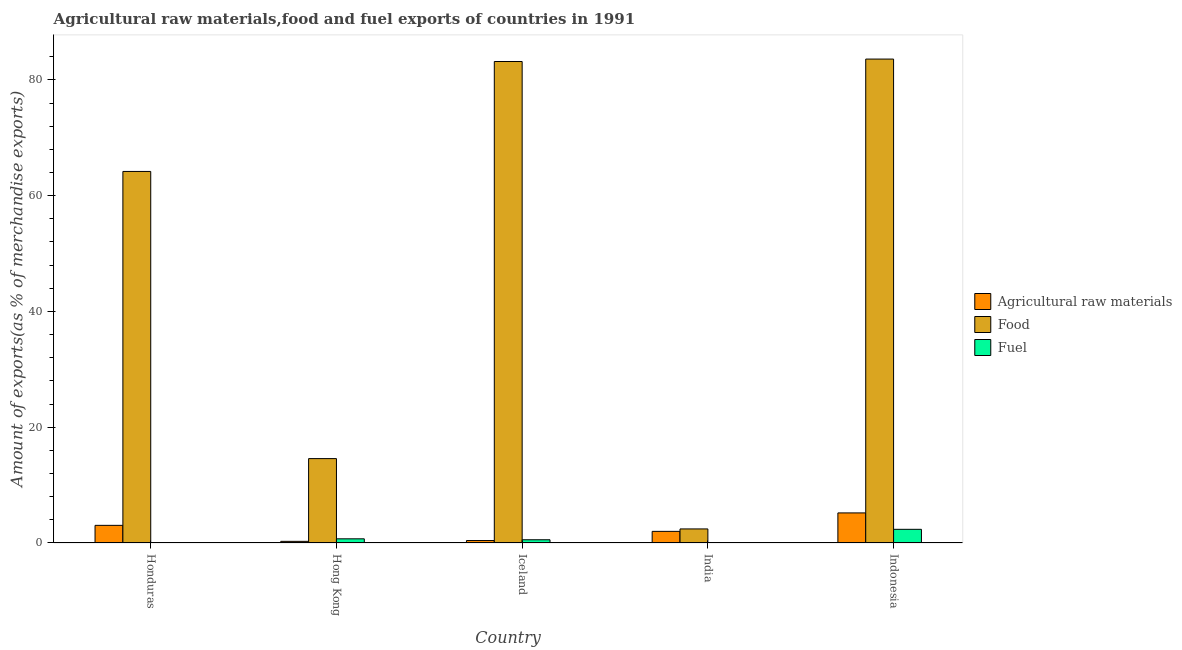How many different coloured bars are there?
Offer a terse response. 3. How many groups of bars are there?
Your answer should be compact. 5. Are the number of bars per tick equal to the number of legend labels?
Make the answer very short. Yes. How many bars are there on the 5th tick from the left?
Your answer should be compact. 3. What is the label of the 3rd group of bars from the left?
Make the answer very short. Iceland. In how many cases, is the number of bars for a given country not equal to the number of legend labels?
Offer a very short reply. 0. What is the percentage of fuel exports in Honduras?
Give a very brief answer. 0.01. Across all countries, what is the maximum percentage of fuel exports?
Ensure brevity in your answer.  2.36. Across all countries, what is the minimum percentage of fuel exports?
Make the answer very short. 0.01. In which country was the percentage of food exports maximum?
Give a very brief answer. Indonesia. In which country was the percentage of raw materials exports minimum?
Offer a terse response. Hong Kong. What is the total percentage of raw materials exports in the graph?
Provide a succinct answer. 10.96. What is the difference between the percentage of fuel exports in Hong Kong and that in Iceland?
Give a very brief answer. 0.16. What is the difference between the percentage of raw materials exports in Honduras and the percentage of food exports in Iceland?
Your answer should be compact. -80.13. What is the average percentage of food exports per country?
Your answer should be very brief. 49.6. What is the difference between the percentage of raw materials exports and percentage of fuel exports in India?
Your answer should be very brief. 1.96. In how many countries, is the percentage of raw materials exports greater than 76 %?
Make the answer very short. 0. What is the ratio of the percentage of food exports in Honduras to that in Indonesia?
Provide a succinct answer. 0.77. What is the difference between the highest and the second highest percentage of raw materials exports?
Offer a very short reply. 2.15. What is the difference between the highest and the lowest percentage of fuel exports?
Ensure brevity in your answer.  2.35. Is the sum of the percentage of fuel exports in Iceland and India greater than the maximum percentage of food exports across all countries?
Your response must be concise. No. What does the 2nd bar from the left in India represents?
Make the answer very short. Food. What does the 1st bar from the right in Indonesia represents?
Your answer should be very brief. Fuel. Is it the case that in every country, the sum of the percentage of raw materials exports and percentage of food exports is greater than the percentage of fuel exports?
Your answer should be very brief. Yes. How many bars are there?
Keep it short and to the point. 15. How many countries are there in the graph?
Provide a short and direct response. 5. Are the values on the major ticks of Y-axis written in scientific E-notation?
Your answer should be compact. No. Does the graph contain any zero values?
Keep it short and to the point. No. How are the legend labels stacked?
Your response must be concise. Vertical. What is the title of the graph?
Your response must be concise. Agricultural raw materials,food and fuel exports of countries in 1991. What is the label or title of the Y-axis?
Provide a short and direct response. Amount of exports(as % of merchandise exports). What is the Amount of exports(as % of merchandise exports) in Agricultural raw materials in Honduras?
Your answer should be very brief. 3.05. What is the Amount of exports(as % of merchandise exports) in Food in Honduras?
Provide a short and direct response. 64.19. What is the Amount of exports(as % of merchandise exports) of Fuel in Honduras?
Offer a very short reply. 0.01. What is the Amount of exports(as % of merchandise exports) in Agricultural raw materials in Hong Kong?
Keep it short and to the point. 0.28. What is the Amount of exports(as % of merchandise exports) of Food in Hong Kong?
Provide a short and direct response. 14.58. What is the Amount of exports(as % of merchandise exports) of Fuel in Hong Kong?
Give a very brief answer. 0.72. What is the Amount of exports(as % of merchandise exports) of Agricultural raw materials in Iceland?
Offer a very short reply. 0.42. What is the Amount of exports(as % of merchandise exports) of Food in Iceland?
Your answer should be very brief. 83.18. What is the Amount of exports(as % of merchandise exports) in Fuel in Iceland?
Ensure brevity in your answer.  0.56. What is the Amount of exports(as % of merchandise exports) of Agricultural raw materials in India?
Offer a very short reply. 2.01. What is the Amount of exports(as % of merchandise exports) in Food in India?
Offer a very short reply. 2.43. What is the Amount of exports(as % of merchandise exports) in Fuel in India?
Provide a short and direct response. 0.05. What is the Amount of exports(as % of merchandise exports) in Agricultural raw materials in Indonesia?
Offer a very short reply. 5.2. What is the Amount of exports(as % of merchandise exports) of Food in Indonesia?
Provide a succinct answer. 83.6. What is the Amount of exports(as % of merchandise exports) in Fuel in Indonesia?
Provide a succinct answer. 2.36. Across all countries, what is the maximum Amount of exports(as % of merchandise exports) of Agricultural raw materials?
Provide a short and direct response. 5.2. Across all countries, what is the maximum Amount of exports(as % of merchandise exports) in Food?
Give a very brief answer. 83.6. Across all countries, what is the maximum Amount of exports(as % of merchandise exports) in Fuel?
Provide a short and direct response. 2.36. Across all countries, what is the minimum Amount of exports(as % of merchandise exports) in Agricultural raw materials?
Provide a short and direct response. 0.28. Across all countries, what is the minimum Amount of exports(as % of merchandise exports) of Food?
Ensure brevity in your answer.  2.43. Across all countries, what is the minimum Amount of exports(as % of merchandise exports) of Fuel?
Make the answer very short. 0.01. What is the total Amount of exports(as % of merchandise exports) of Agricultural raw materials in the graph?
Your answer should be very brief. 10.96. What is the total Amount of exports(as % of merchandise exports) in Food in the graph?
Provide a succinct answer. 247.98. What is the total Amount of exports(as % of merchandise exports) of Fuel in the graph?
Offer a terse response. 3.7. What is the difference between the Amount of exports(as % of merchandise exports) in Agricultural raw materials in Honduras and that in Hong Kong?
Give a very brief answer. 2.76. What is the difference between the Amount of exports(as % of merchandise exports) of Food in Honduras and that in Hong Kong?
Your response must be concise. 49.61. What is the difference between the Amount of exports(as % of merchandise exports) of Fuel in Honduras and that in Hong Kong?
Keep it short and to the point. -0.71. What is the difference between the Amount of exports(as % of merchandise exports) in Agricultural raw materials in Honduras and that in Iceland?
Provide a short and direct response. 2.62. What is the difference between the Amount of exports(as % of merchandise exports) of Food in Honduras and that in Iceland?
Offer a very short reply. -18.99. What is the difference between the Amount of exports(as % of merchandise exports) of Fuel in Honduras and that in Iceland?
Offer a very short reply. -0.55. What is the difference between the Amount of exports(as % of merchandise exports) in Agricultural raw materials in Honduras and that in India?
Provide a succinct answer. 1.04. What is the difference between the Amount of exports(as % of merchandise exports) of Food in Honduras and that in India?
Provide a short and direct response. 61.76. What is the difference between the Amount of exports(as % of merchandise exports) of Fuel in Honduras and that in India?
Provide a short and direct response. -0.04. What is the difference between the Amount of exports(as % of merchandise exports) of Agricultural raw materials in Honduras and that in Indonesia?
Your response must be concise. -2.15. What is the difference between the Amount of exports(as % of merchandise exports) of Food in Honduras and that in Indonesia?
Offer a terse response. -19.41. What is the difference between the Amount of exports(as % of merchandise exports) in Fuel in Honduras and that in Indonesia?
Give a very brief answer. -2.35. What is the difference between the Amount of exports(as % of merchandise exports) in Agricultural raw materials in Hong Kong and that in Iceland?
Your answer should be compact. -0.14. What is the difference between the Amount of exports(as % of merchandise exports) of Food in Hong Kong and that in Iceland?
Ensure brevity in your answer.  -68.6. What is the difference between the Amount of exports(as % of merchandise exports) in Fuel in Hong Kong and that in Iceland?
Give a very brief answer. 0.16. What is the difference between the Amount of exports(as % of merchandise exports) in Agricultural raw materials in Hong Kong and that in India?
Provide a succinct answer. -1.73. What is the difference between the Amount of exports(as % of merchandise exports) in Food in Hong Kong and that in India?
Your response must be concise. 12.15. What is the difference between the Amount of exports(as % of merchandise exports) in Fuel in Hong Kong and that in India?
Offer a terse response. 0.67. What is the difference between the Amount of exports(as % of merchandise exports) in Agricultural raw materials in Hong Kong and that in Indonesia?
Your answer should be very brief. -4.91. What is the difference between the Amount of exports(as % of merchandise exports) of Food in Hong Kong and that in Indonesia?
Your response must be concise. -69.02. What is the difference between the Amount of exports(as % of merchandise exports) of Fuel in Hong Kong and that in Indonesia?
Offer a terse response. -1.64. What is the difference between the Amount of exports(as % of merchandise exports) in Agricultural raw materials in Iceland and that in India?
Keep it short and to the point. -1.59. What is the difference between the Amount of exports(as % of merchandise exports) of Food in Iceland and that in India?
Offer a very short reply. 80.75. What is the difference between the Amount of exports(as % of merchandise exports) of Fuel in Iceland and that in India?
Provide a short and direct response. 0.51. What is the difference between the Amount of exports(as % of merchandise exports) in Agricultural raw materials in Iceland and that in Indonesia?
Your response must be concise. -4.77. What is the difference between the Amount of exports(as % of merchandise exports) in Food in Iceland and that in Indonesia?
Your answer should be compact. -0.42. What is the difference between the Amount of exports(as % of merchandise exports) of Fuel in Iceland and that in Indonesia?
Make the answer very short. -1.8. What is the difference between the Amount of exports(as % of merchandise exports) in Agricultural raw materials in India and that in Indonesia?
Provide a succinct answer. -3.19. What is the difference between the Amount of exports(as % of merchandise exports) in Food in India and that in Indonesia?
Offer a very short reply. -81.17. What is the difference between the Amount of exports(as % of merchandise exports) in Fuel in India and that in Indonesia?
Keep it short and to the point. -2.31. What is the difference between the Amount of exports(as % of merchandise exports) of Agricultural raw materials in Honduras and the Amount of exports(as % of merchandise exports) of Food in Hong Kong?
Your response must be concise. -11.53. What is the difference between the Amount of exports(as % of merchandise exports) in Agricultural raw materials in Honduras and the Amount of exports(as % of merchandise exports) in Fuel in Hong Kong?
Provide a succinct answer. 2.33. What is the difference between the Amount of exports(as % of merchandise exports) in Food in Honduras and the Amount of exports(as % of merchandise exports) in Fuel in Hong Kong?
Your response must be concise. 63.47. What is the difference between the Amount of exports(as % of merchandise exports) in Agricultural raw materials in Honduras and the Amount of exports(as % of merchandise exports) in Food in Iceland?
Your answer should be compact. -80.13. What is the difference between the Amount of exports(as % of merchandise exports) in Agricultural raw materials in Honduras and the Amount of exports(as % of merchandise exports) in Fuel in Iceland?
Offer a terse response. 2.49. What is the difference between the Amount of exports(as % of merchandise exports) in Food in Honduras and the Amount of exports(as % of merchandise exports) in Fuel in Iceland?
Keep it short and to the point. 63.63. What is the difference between the Amount of exports(as % of merchandise exports) in Agricultural raw materials in Honduras and the Amount of exports(as % of merchandise exports) in Food in India?
Offer a terse response. 0.62. What is the difference between the Amount of exports(as % of merchandise exports) of Agricultural raw materials in Honduras and the Amount of exports(as % of merchandise exports) of Fuel in India?
Make the answer very short. 3. What is the difference between the Amount of exports(as % of merchandise exports) of Food in Honduras and the Amount of exports(as % of merchandise exports) of Fuel in India?
Give a very brief answer. 64.14. What is the difference between the Amount of exports(as % of merchandise exports) in Agricultural raw materials in Honduras and the Amount of exports(as % of merchandise exports) in Food in Indonesia?
Your answer should be very brief. -80.56. What is the difference between the Amount of exports(as % of merchandise exports) of Agricultural raw materials in Honduras and the Amount of exports(as % of merchandise exports) of Fuel in Indonesia?
Ensure brevity in your answer.  0.68. What is the difference between the Amount of exports(as % of merchandise exports) in Food in Honduras and the Amount of exports(as % of merchandise exports) in Fuel in Indonesia?
Provide a short and direct response. 61.83. What is the difference between the Amount of exports(as % of merchandise exports) of Agricultural raw materials in Hong Kong and the Amount of exports(as % of merchandise exports) of Food in Iceland?
Give a very brief answer. -82.9. What is the difference between the Amount of exports(as % of merchandise exports) in Agricultural raw materials in Hong Kong and the Amount of exports(as % of merchandise exports) in Fuel in Iceland?
Make the answer very short. -0.28. What is the difference between the Amount of exports(as % of merchandise exports) of Food in Hong Kong and the Amount of exports(as % of merchandise exports) of Fuel in Iceland?
Offer a very short reply. 14.02. What is the difference between the Amount of exports(as % of merchandise exports) of Agricultural raw materials in Hong Kong and the Amount of exports(as % of merchandise exports) of Food in India?
Your response must be concise. -2.14. What is the difference between the Amount of exports(as % of merchandise exports) in Agricultural raw materials in Hong Kong and the Amount of exports(as % of merchandise exports) in Fuel in India?
Offer a terse response. 0.23. What is the difference between the Amount of exports(as % of merchandise exports) in Food in Hong Kong and the Amount of exports(as % of merchandise exports) in Fuel in India?
Make the answer very short. 14.53. What is the difference between the Amount of exports(as % of merchandise exports) of Agricultural raw materials in Hong Kong and the Amount of exports(as % of merchandise exports) of Food in Indonesia?
Keep it short and to the point. -83.32. What is the difference between the Amount of exports(as % of merchandise exports) in Agricultural raw materials in Hong Kong and the Amount of exports(as % of merchandise exports) in Fuel in Indonesia?
Ensure brevity in your answer.  -2.08. What is the difference between the Amount of exports(as % of merchandise exports) of Food in Hong Kong and the Amount of exports(as % of merchandise exports) of Fuel in Indonesia?
Offer a very short reply. 12.22. What is the difference between the Amount of exports(as % of merchandise exports) of Agricultural raw materials in Iceland and the Amount of exports(as % of merchandise exports) of Food in India?
Your answer should be very brief. -2.01. What is the difference between the Amount of exports(as % of merchandise exports) in Agricultural raw materials in Iceland and the Amount of exports(as % of merchandise exports) in Fuel in India?
Offer a very short reply. 0.37. What is the difference between the Amount of exports(as % of merchandise exports) in Food in Iceland and the Amount of exports(as % of merchandise exports) in Fuel in India?
Provide a succinct answer. 83.13. What is the difference between the Amount of exports(as % of merchandise exports) in Agricultural raw materials in Iceland and the Amount of exports(as % of merchandise exports) in Food in Indonesia?
Ensure brevity in your answer.  -83.18. What is the difference between the Amount of exports(as % of merchandise exports) in Agricultural raw materials in Iceland and the Amount of exports(as % of merchandise exports) in Fuel in Indonesia?
Provide a short and direct response. -1.94. What is the difference between the Amount of exports(as % of merchandise exports) of Food in Iceland and the Amount of exports(as % of merchandise exports) of Fuel in Indonesia?
Offer a terse response. 80.82. What is the difference between the Amount of exports(as % of merchandise exports) of Agricultural raw materials in India and the Amount of exports(as % of merchandise exports) of Food in Indonesia?
Keep it short and to the point. -81.59. What is the difference between the Amount of exports(as % of merchandise exports) in Agricultural raw materials in India and the Amount of exports(as % of merchandise exports) in Fuel in Indonesia?
Give a very brief answer. -0.35. What is the difference between the Amount of exports(as % of merchandise exports) in Food in India and the Amount of exports(as % of merchandise exports) in Fuel in Indonesia?
Your answer should be compact. 0.07. What is the average Amount of exports(as % of merchandise exports) of Agricultural raw materials per country?
Offer a very short reply. 2.19. What is the average Amount of exports(as % of merchandise exports) in Food per country?
Your answer should be compact. 49.6. What is the average Amount of exports(as % of merchandise exports) in Fuel per country?
Your response must be concise. 0.74. What is the difference between the Amount of exports(as % of merchandise exports) of Agricultural raw materials and Amount of exports(as % of merchandise exports) of Food in Honduras?
Provide a succinct answer. -61.14. What is the difference between the Amount of exports(as % of merchandise exports) of Agricultural raw materials and Amount of exports(as % of merchandise exports) of Fuel in Honduras?
Provide a succinct answer. 3.03. What is the difference between the Amount of exports(as % of merchandise exports) in Food and Amount of exports(as % of merchandise exports) in Fuel in Honduras?
Offer a very short reply. 64.18. What is the difference between the Amount of exports(as % of merchandise exports) of Agricultural raw materials and Amount of exports(as % of merchandise exports) of Food in Hong Kong?
Ensure brevity in your answer.  -14.3. What is the difference between the Amount of exports(as % of merchandise exports) in Agricultural raw materials and Amount of exports(as % of merchandise exports) in Fuel in Hong Kong?
Your response must be concise. -0.44. What is the difference between the Amount of exports(as % of merchandise exports) of Food and Amount of exports(as % of merchandise exports) of Fuel in Hong Kong?
Offer a terse response. 13.86. What is the difference between the Amount of exports(as % of merchandise exports) of Agricultural raw materials and Amount of exports(as % of merchandise exports) of Food in Iceland?
Ensure brevity in your answer.  -82.76. What is the difference between the Amount of exports(as % of merchandise exports) in Agricultural raw materials and Amount of exports(as % of merchandise exports) in Fuel in Iceland?
Give a very brief answer. -0.14. What is the difference between the Amount of exports(as % of merchandise exports) of Food and Amount of exports(as % of merchandise exports) of Fuel in Iceland?
Your response must be concise. 82.62. What is the difference between the Amount of exports(as % of merchandise exports) in Agricultural raw materials and Amount of exports(as % of merchandise exports) in Food in India?
Offer a terse response. -0.42. What is the difference between the Amount of exports(as % of merchandise exports) in Agricultural raw materials and Amount of exports(as % of merchandise exports) in Fuel in India?
Offer a very short reply. 1.96. What is the difference between the Amount of exports(as % of merchandise exports) of Food and Amount of exports(as % of merchandise exports) of Fuel in India?
Offer a very short reply. 2.38. What is the difference between the Amount of exports(as % of merchandise exports) of Agricultural raw materials and Amount of exports(as % of merchandise exports) of Food in Indonesia?
Provide a succinct answer. -78.41. What is the difference between the Amount of exports(as % of merchandise exports) in Agricultural raw materials and Amount of exports(as % of merchandise exports) in Fuel in Indonesia?
Provide a succinct answer. 2.83. What is the difference between the Amount of exports(as % of merchandise exports) in Food and Amount of exports(as % of merchandise exports) in Fuel in Indonesia?
Make the answer very short. 81.24. What is the ratio of the Amount of exports(as % of merchandise exports) of Agricultural raw materials in Honduras to that in Hong Kong?
Give a very brief answer. 10.78. What is the ratio of the Amount of exports(as % of merchandise exports) of Food in Honduras to that in Hong Kong?
Provide a succinct answer. 4.4. What is the ratio of the Amount of exports(as % of merchandise exports) in Fuel in Honduras to that in Hong Kong?
Offer a terse response. 0.02. What is the ratio of the Amount of exports(as % of merchandise exports) of Agricultural raw materials in Honduras to that in Iceland?
Keep it short and to the point. 7.21. What is the ratio of the Amount of exports(as % of merchandise exports) of Food in Honduras to that in Iceland?
Give a very brief answer. 0.77. What is the ratio of the Amount of exports(as % of merchandise exports) in Fuel in Honduras to that in Iceland?
Offer a terse response. 0.02. What is the ratio of the Amount of exports(as % of merchandise exports) in Agricultural raw materials in Honduras to that in India?
Your answer should be very brief. 1.52. What is the ratio of the Amount of exports(as % of merchandise exports) of Food in Honduras to that in India?
Provide a short and direct response. 26.44. What is the ratio of the Amount of exports(as % of merchandise exports) of Fuel in Honduras to that in India?
Your response must be concise. 0.23. What is the ratio of the Amount of exports(as % of merchandise exports) of Agricultural raw materials in Honduras to that in Indonesia?
Offer a terse response. 0.59. What is the ratio of the Amount of exports(as % of merchandise exports) of Food in Honduras to that in Indonesia?
Your answer should be very brief. 0.77. What is the ratio of the Amount of exports(as % of merchandise exports) of Fuel in Honduras to that in Indonesia?
Keep it short and to the point. 0. What is the ratio of the Amount of exports(as % of merchandise exports) in Agricultural raw materials in Hong Kong to that in Iceland?
Make the answer very short. 0.67. What is the ratio of the Amount of exports(as % of merchandise exports) in Food in Hong Kong to that in Iceland?
Offer a very short reply. 0.18. What is the ratio of the Amount of exports(as % of merchandise exports) of Fuel in Hong Kong to that in Iceland?
Give a very brief answer. 1.29. What is the ratio of the Amount of exports(as % of merchandise exports) in Agricultural raw materials in Hong Kong to that in India?
Your answer should be very brief. 0.14. What is the ratio of the Amount of exports(as % of merchandise exports) of Food in Hong Kong to that in India?
Provide a succinct answer. 6.01. What is the ratio of the Amount of exports(as % of merchandise exports) of Fuel in Hong Kong to that in India?
Keep it short and to the point. 14.62. What is the ratio of the Amount of exports(as % of merchandise exports) of Agricultural raw materials in Hong Kong to that in Indonesia?
Ensure brevity in your answer.  0.05. What is the ratio of the Amount of exports(as % of merchandise exports) in Food in Hong Kong to that in Indonesia?
Offer a very short reply. 0.17. What is the ratio of the Amount of exports(as % of merchandise exports) of Fuel in Hong Kong to that in Indonesia?
Offer a very short reply. 0.3. What is the ratio of the Amount of exports(as % of merchandise exports) of Agricultural raw materials in Iceland to that in India?
Give a very brief answer. 0.21. What is the ratio of the Amount of exports(as % of merchandise exports) in Food in Iceland to that in India?
Your answer should be compact. 34.27. What is the ratio of the Amount of exports(as % of merchandise exports) in Fuel in Iceland to that in India?
Provide a short and direct response. 11.33. What is the ratio of the Amount of exports(as % of merchandise exports) in Agricultural raw materials in Iceland to that in Indonesia?
Your response must be concise. 0.08. What is the ratio of the Amount of exports(as % of merchandise exports) in Food in Iceland to that in Indonesia?
Your response must be concise. 0.99. What is the ratio of the Amount of exports(as % of merchandise exports) in Fuel in Iceland to that in Indonesia?
Your answer should be compact. 0.24. What is the ratio of the Amount of exports(as % of merchandise exports) of Agricultural raw materials in India to that in Indonesia?
Offer a very short reply. 0.39. What is the ratio of the Amount of exports(as % of merchandise exports) of Food in India to that in Indonesia?
Keep it short and to the point. 0.03. What is the ratio of the Amount of exports(as % of merchandise exports) of Fuel in India to that in Indonesia?
Offer a very short reply. 0.02. What is the difference between the highest and the second highest Amount of exports(as % of merchandise exports) of Agricultural raw materials?
Make the answer very short. 2.15. What is the difference between the highest and the second highest Amount of exports(as % of merchandise exports) of Food?
Your answer should be compact. 0.42. What is the difference between the highest and the second highest Amount of exports(as % of merchandise exports) of Fuel?
Your answer should be very brief. 1.64. What is the difference between the highest and the lowest Amount of exports(as % of merchandise exports) in Agricultural raw materials?
Offer a terse response. 4.91. What is the difference between the highest and the lowest Amount of exports(as % of merchandise exports) of Food?
Provide a succinct answer. 81.17. What is the difference between the highest and the lowest Amount of exports(as % of merchandise exports) of Fuel?
Your response must be concise. 2.35. 